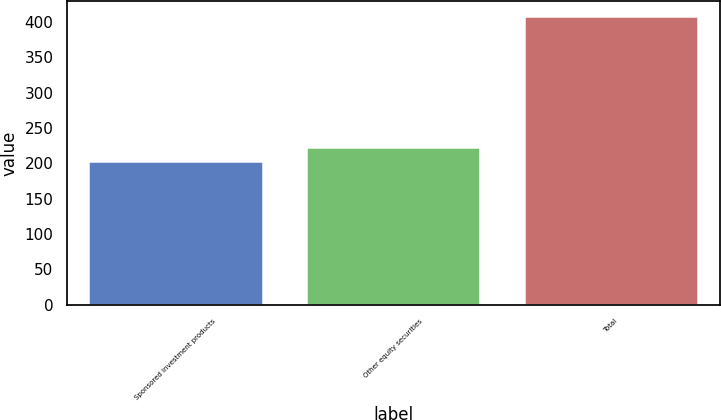Convert chart to OTSL. <chart><loc_0><loc_0><loc_500><loc_500><bar_chart><fcel>Sponsored investment products<fcel>Other equity securities<fcel>Total<nl><fcel>203<fcel>223.6<fcel>409<nl></chart> 